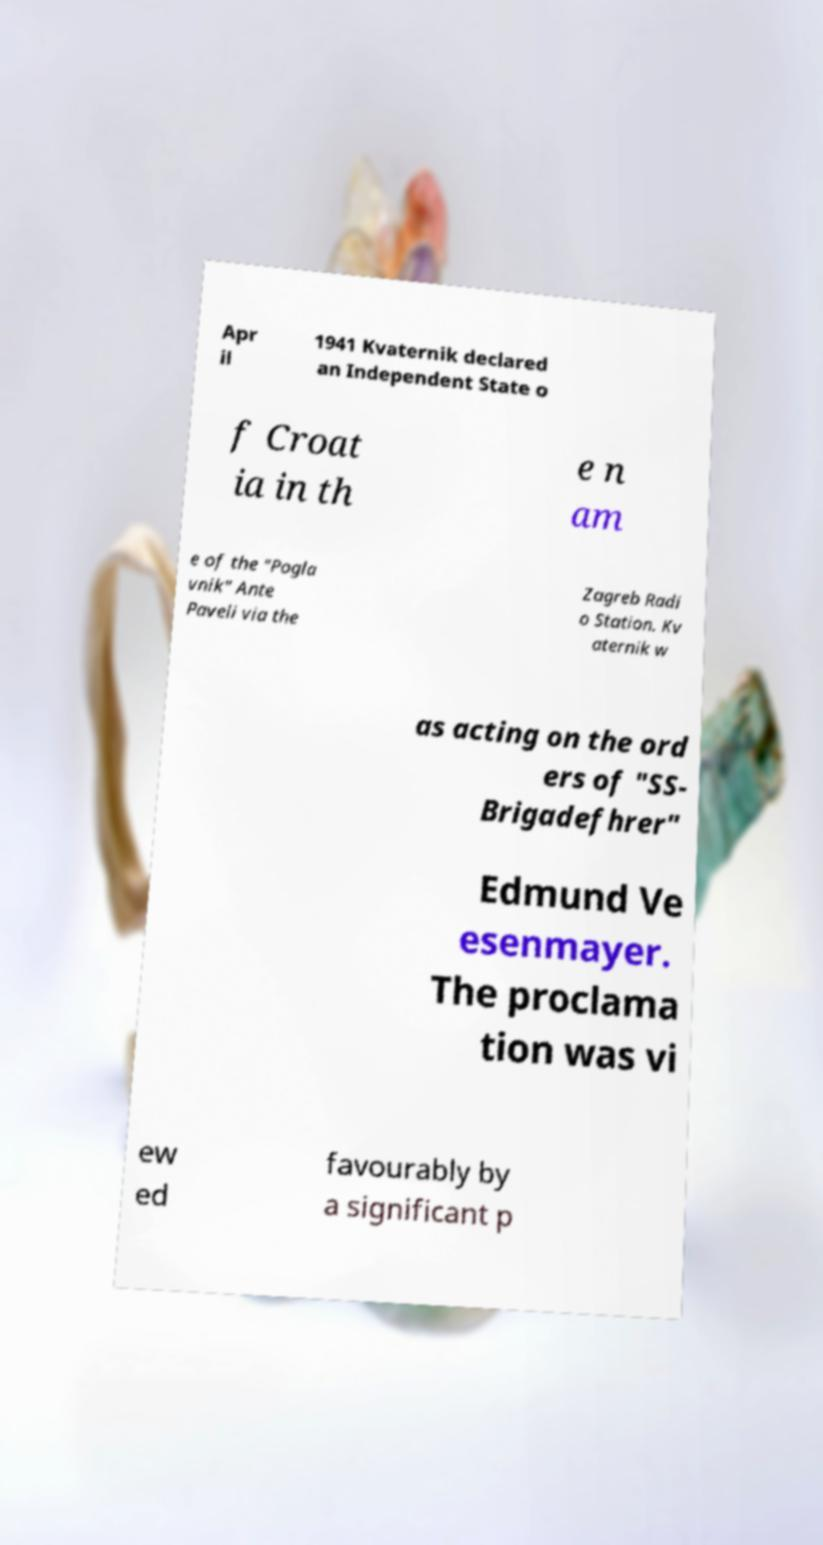What messages or text are displayed in this image? I need them in a readable, typed format. Apr il 1941 Kvaternik declared an Independent State o f Croat ia in th e n am e of the "Pogla vnik" Ante Paveli via the Zagreb Radi o Station. Kv aternik w as acting on the ord ers of "SS- Brigadefhrer" Edmund Ve esenmayer. The proclama tion was vi ew ed favourably by a significant p 